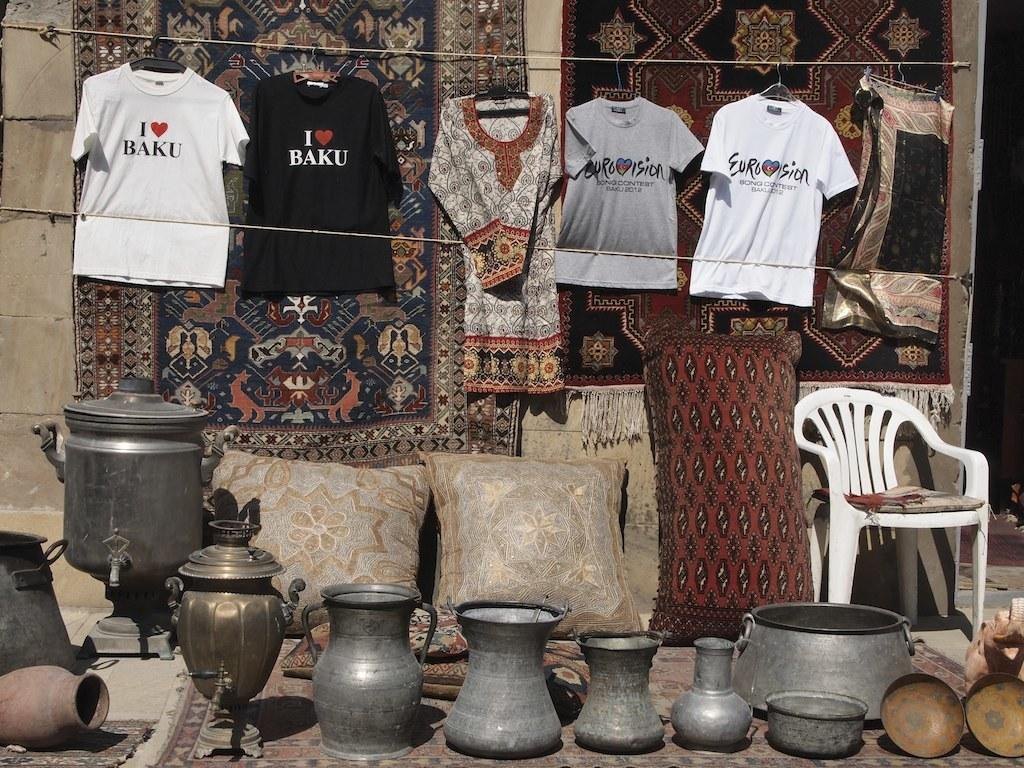<image>
Describe the image concisely. Shirts hanging with one that says I love Baku. 